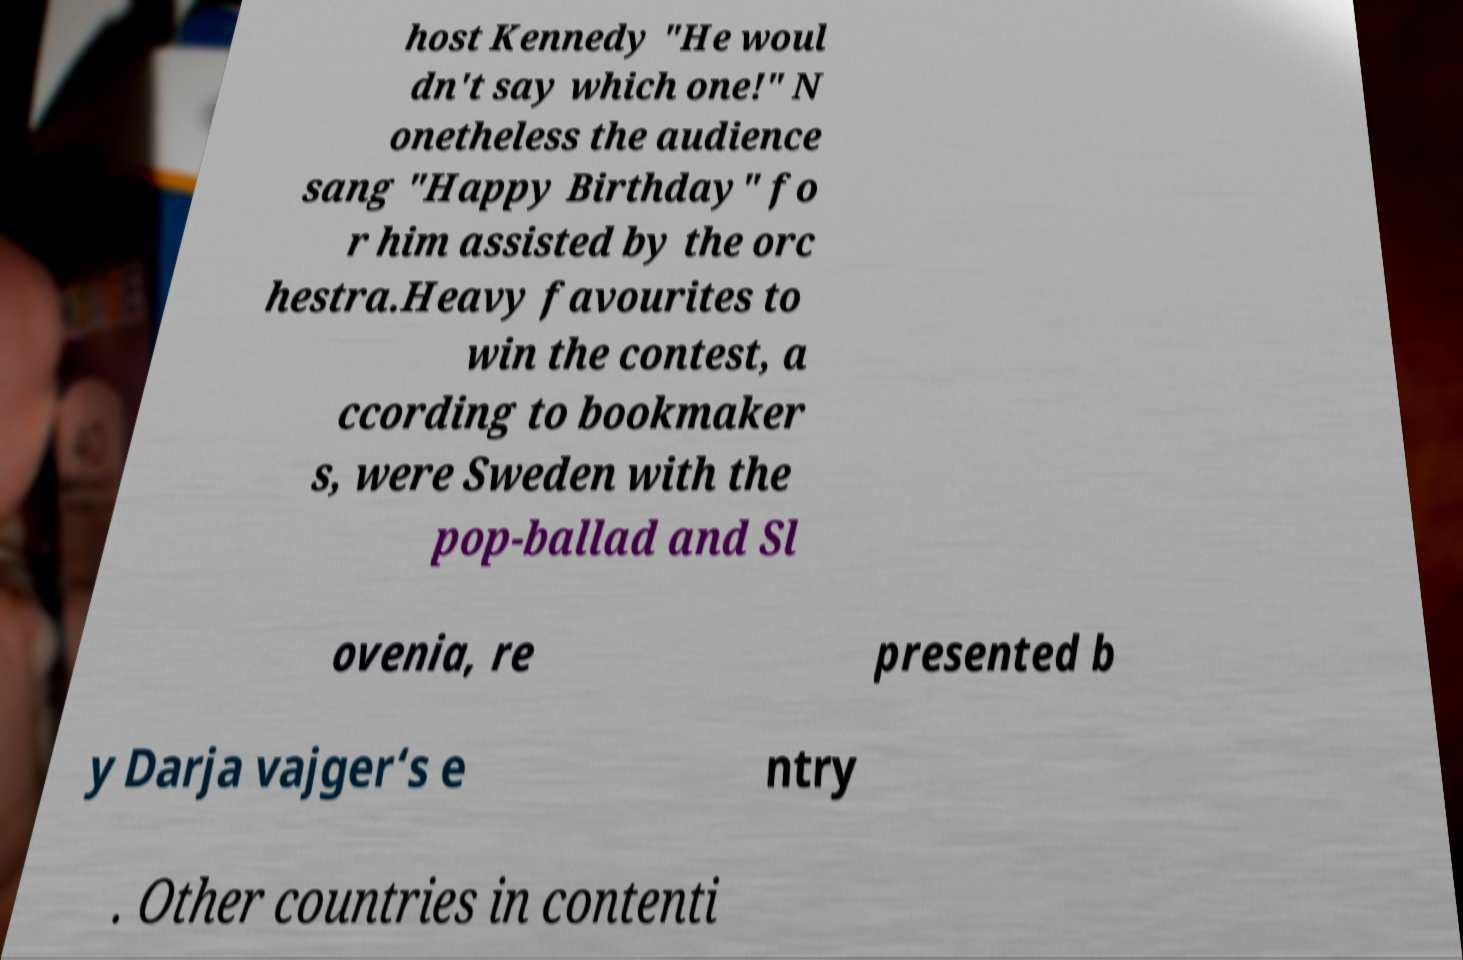For documentation purposes, I need the text within this image transcribed. Could you provide that? host Kennedy "He woul dn't say which one!" N onetheless the audience sang "Happy Birthday" fo r him assisted by the orc hestra.Heavy favourites to win the contest, a ccording to bookmaker s, were Sweden with the pop-ballad and Sl ovenia, re presented b y Darja vajger‘s e ntry . Other countries in contenti 